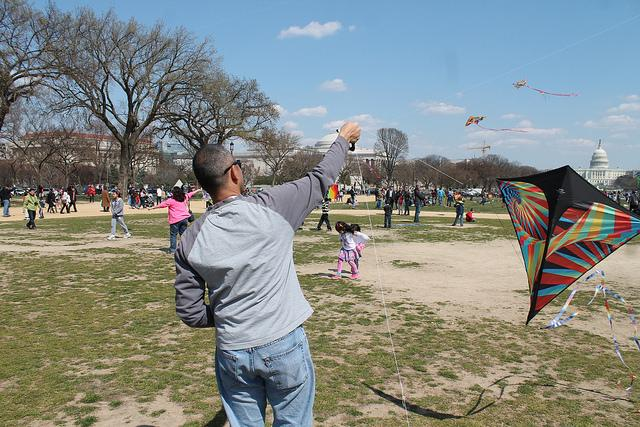Where would more well known government workers work here?

Choices:
A) rightmost building
B) middle building
C) leftmost building
D) park rightmost building 